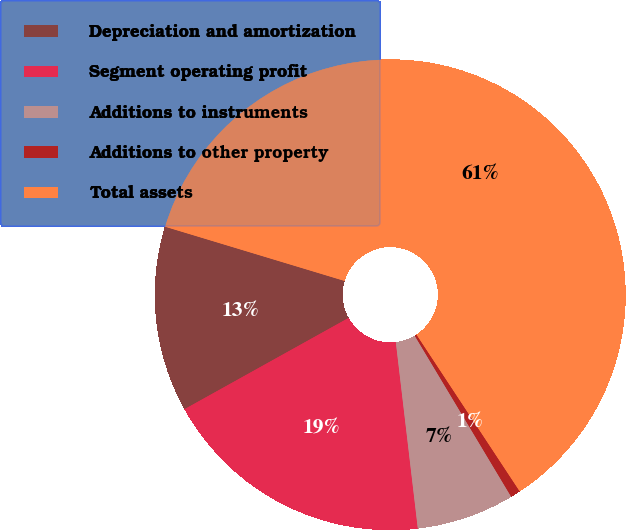Convert chart to OTSL. <chart><loc_0><loc_0><loc_500><loc_500><pie_chart><fcel>Depreciation and amortization<fcel>Segment operating profit<fcel>Additions to instruments<fcel>Additions to other property<fcel>Total assets<nl><fcel>12.75%<fcel>18.79%<fcel>6.72%<fcel>0.68%<fcel>61.06%<nl></chart> 